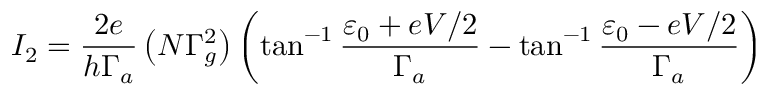<formula> <loc_0><loc_0><loc_500><loc_500>I _ { 2 } = \frac { 2 e } { h \Gamma _ { a } } \left ( N \Gamma _ { g } ^ { 2 } \right ) \left ( \tan ^ { - 1 } \frac { \varepsilon _ { 0 } + e V / 2 } { \Gamma _ { a } } - \tan ^ { - 1 } \frac { \varepsilon _ { 0 } - e V / 2 } { \Gamma _ { a } } \right )</formula> 